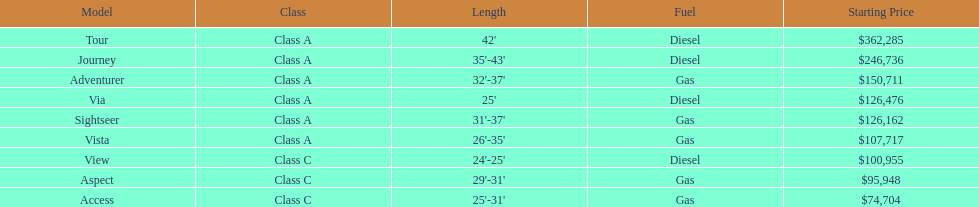Which model has the lowest started price? Access. 